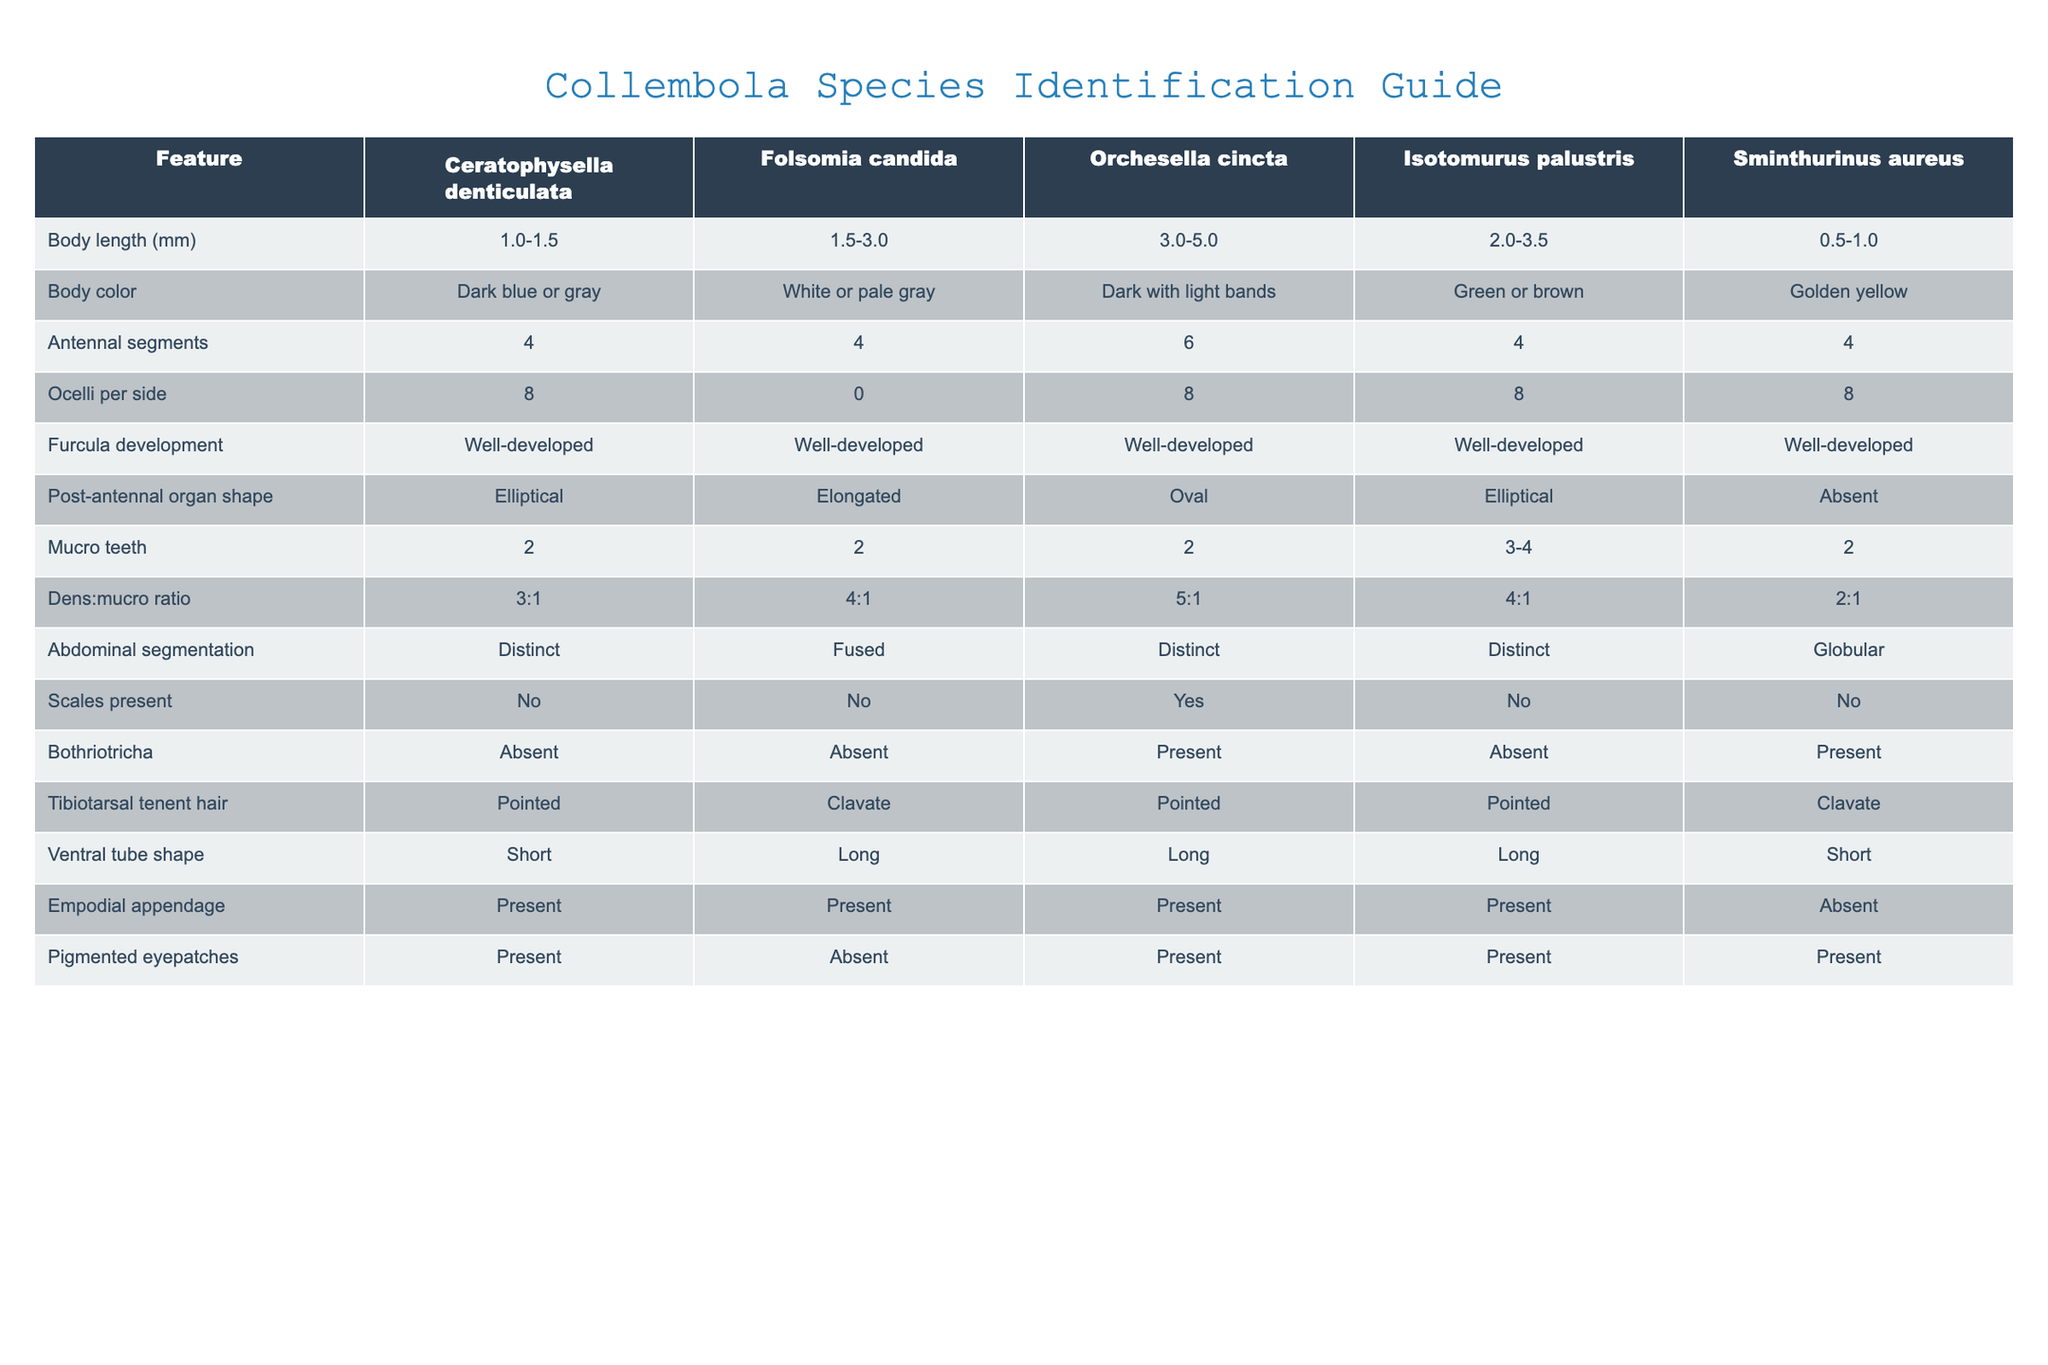What is the body length range of Orchesella cincta? The body length range is listed in the table under the "Body length (mm)" column for Orchesella cincta. It states the range as 3.0-5.0 mm.
Answer: 3.0-5.0 mm How many ocelli per side does Folsomia candida have? The number of ocelli per side for Folsomia candida is directly provided in the table under the "Ocelli per side" column. It shows the value as 0.
Answer: 0 Do Sminthurinus aureus have scales present? The table indicates whether scales are present under the "Scales present" column for Sminthurinus aureus. It is marked as "No."
Answer: No What is the density to mucro ratio of Ceratophysella denticulata? The density to mucro ratio for Ceratophysella denticulata can be found in the "Dens:mucro ratio" column, and it is stated as 3:1.
Answer: 3:1 Which species has the longest tibiotarsal tenent hair? By comparing the "Tibiotarsal tenent hair" column, we can see that both Folsomia candida and Sminthurinus aureus are listed as having "Clavate." However, to find which species has the longest hair, one would consider "Clavate" to be longer than "Pointed," and since both clavate species are Folsomia candida and Sminthurinus aureus, it shows that they may be equivalent in this characteristic, but there is no direct comparison of length given in the table.
Answer: Cannot determine from the table Which species has a ventral tube shape of "Short"? To find the species with a "Short" ventral tube shape, we look in the "Ventral tube shape" column. It shows that both Ceratophysella denticulata and Sminthurinus aureus have a "Short" ventral tube shape.
Answer: Ceratophysella denticulata, Sminthurinus aureus What is the average body length range of the listed Collembola species? To find the average body length, we first extract each species' body length ranges numerically: Ceratophysella denticulata (1.0-1.5), Folsomia candida (1.5-3.0), Orchesella cincta (3.0-5.0), Isotomurus palustris (2.0-3.5), and Sminthurinus aureus (0.5-1.0). The ranges can be averaged by taking the numerical midpoint for each: (1.25, 2.25, 4.0, 2.75, 0.75). Finding the overall average involves summing these midpoints (1.25+2.25+4.0+2.75+0.75=11.0) and dividing by the number of species (5), resulting in an average of 2.2 mm.
Answer: 2.2 mm Is Orchesella cincta the only species with pigmented eyepatches? The "Pigmented eyepatches" column indicates a "Present" status for Orchesella cincta and two other species (Ceratophysella denticulata and Isotomurus palustris). Therefore, Orchesella cincta is not the only species with pigmented eyepatches.
Answer: No 